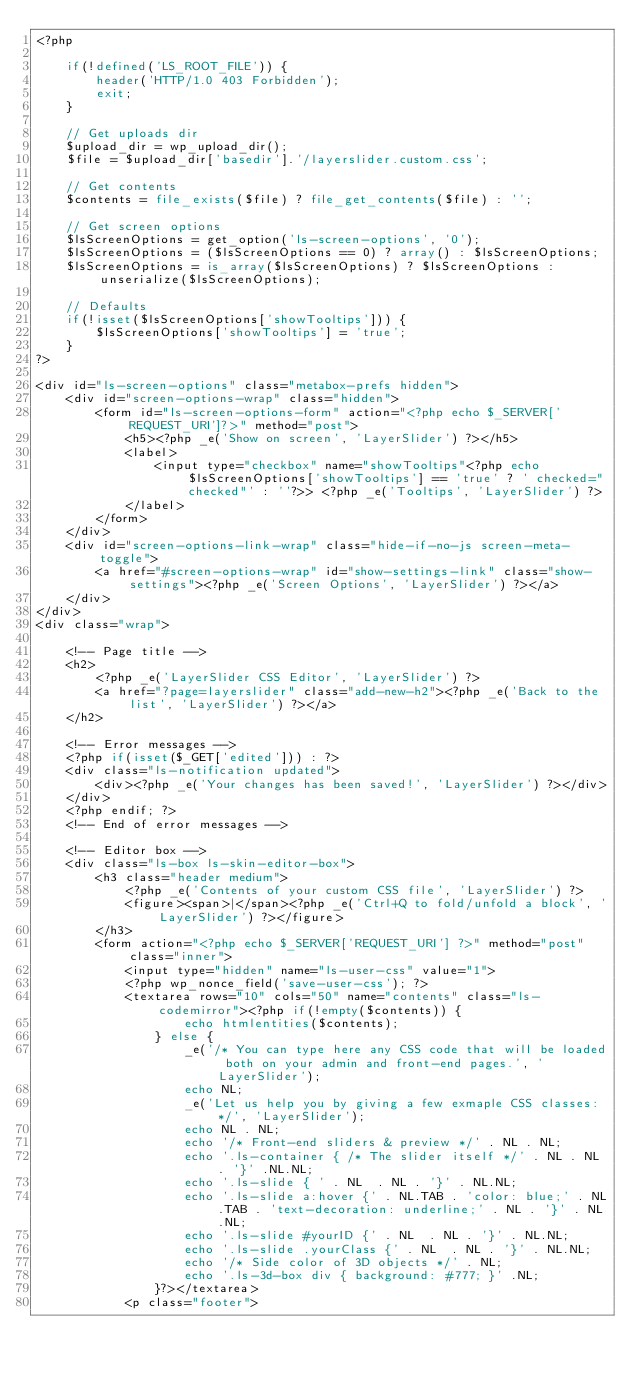<code> <loc_0><loc_0><loc_500><loc_500><_PHP_><?php

	if(!defined('LS_ROOT_FILE')) { 
		header('HTTP/1.0 403 Forbidden');
		exit;
	}

	// Get uploads dir
	$upload_dir = wp_upload_dir();
	$file = $upload_dir['basedir'].'/layerslider.custom.css';

	// Get contents
	$contents = file_exists($file) ? file_get_contents($file) : '';

	// Get screen options
	$lsScreenOptions = get_option('ls-screen-options', '0');
	$lsScreenOptions = ($lsScreenOptions == 0) ? array() : $lsScreenOptions;
	$lsScreenOptions = is_array($lsScreenOptions) ? $lsScreenOptions : unserialize($lsScreenOptions);

	// Defaults
	if(!isset($lsScreenOptions['showTooltips'])) {
		$lsScreenOptions['showTooltips'] = 'true';
	}
?>

<div id="ls-screen-options" class="metabox-prefs hidden">
	<div id="screen-options-wrap" class="hidden">
		<form id="ls-screen-options-form" action="<?php echo $_SERVER['REQUEST_URI']?>" method="post">
			<h5><?php _e('Show on screen', 'LayerSlider') ?></h5>
			<label>
				<input type="checkbox" name="showTooltips"<?php echo $lsScreenOptions['showTooltips'] == 'true' ? ' checked="checked"' : ''?>> <?php _e('Tooltips', 'LayerSlider') ?>
			</label>
		</form>
	</div>
	<div id="screen-options-link-wrap" class="hide-if-no-js screen-meta-toggle">
		<a href="#screen-options-wrap" id="show-settings-link" class="show-settings"><?php _e('Screen Options', 'LayerSlider') ?></a>
	</div>
</div>
<div class="wrap">

	<!-- Page title -->
	<h2>
		<?php _e('LayerSlider CSS Editor', 'LayerSlider') ?>
		<a href="?page=layerslider" class="add-new-h2"><?php _e('Back to the list', 'LayerSlider') ?></a>
	</h2>

	<!-- Error messages -->
	<?php if(isset($_GET['edited'])) : ?>
	<div class="ls-notification updated">
		<div><?php _e('Your changes has been saved!', 'LayerSlider') ?></div>
	</div>
	<?php endif; ?>
	<!-- End of error messages -->

	<!-- Editor box -->
	<div class="ls-box ls-skin-editor-box">
		<h3 class="header medium">
			<?php _e('Contents of your custom CSS file', 'LayerSlider') ?>
			<figure><span>|</span><?php _e('Ctrl+Q to fold/unfold a block', 'LayerSlider') ?></figure>
		</h3>
		<form action="<?php echo $_SERVER['REQUEST_URI'] ?>" method="post" class="inner">
			<input type="hidden" name="ls-user-css" value="1">
			<?php wp_nonce_field('save-user-css'); ?>
			<textarea rows="10" cols="50" name="contents" class="ls-codemirror"><?php if(!empty($contents)) {
					echo htmlentities($contents);
				} else {
					_e('/* You can type here any CSS code that will be loaded both on your admin and front-end pages.', 'LayerSlider');
					echo NL;
					_e('Let us help you by giving a few exmaple CSS classes: */', 'LayerSlider');
					echo NL . NL;
					echo '/* Front-end sliders & preview */' . NL . NL;
					echo '.ls-container { /* The slider itself */' . NL . NL . '}' .NL.NL;
					echo '.ls-slide { ' . NL  . NL . '}' . NL.NL;
					echo '.ls-slide a:hover {' . NL.TAB . 'color: blue;' . NL.TAB . 'text-decoration: underline;' . NL . '}' . NL.NL;
					echo '.ls-slide #yourID {' . NL  . NL . '}' . NL.NL;
					echo '.ls-slide .yourClass {' . NL  . NL . '}' . NL.NL;
					echo '/* Side color of 3D objects */' . NL;
					echo '.ls-3d-box div { background: #777; }' .NL;
				}?></textarea>
			<p class="footer"></code> 